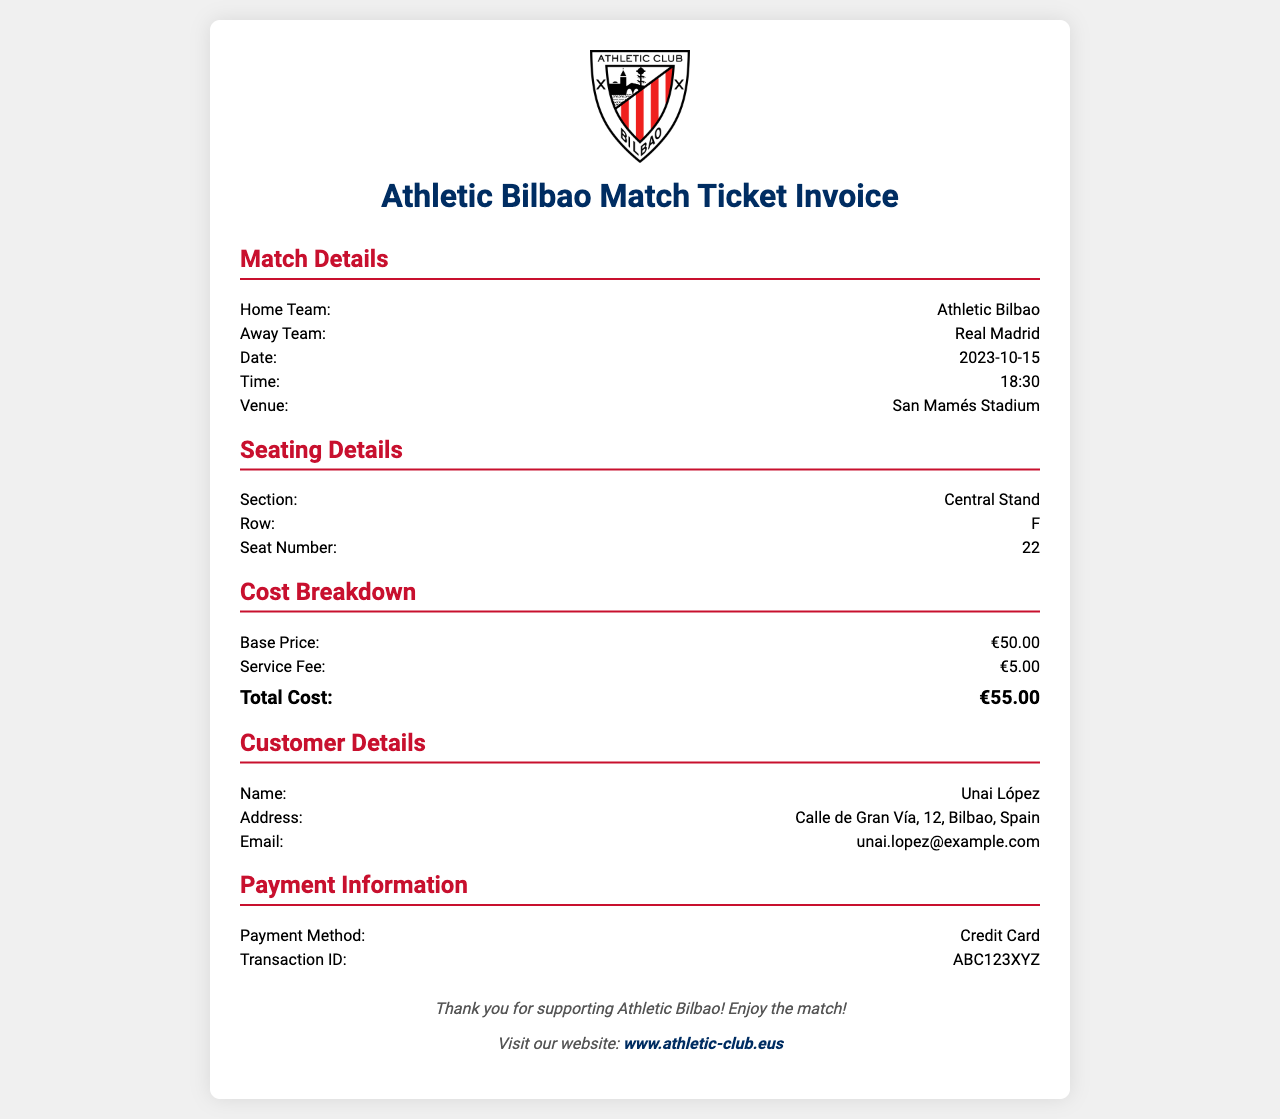What is the date of the match? The date of the match is provided in the match details section of the document.
Answer: 2023-10-15 Who is the away team? The away team is listed under the match details section of the document.
Answer: Real Madrid What is the section of the seat? The section of the seat is mentioned in the seating details section.
Answer: Central Stand What is the total cost of the ticket? The total cost of the ticket is summarized in the cost breakdown section of the document.
Answer: €55.00 What payment method was used? The payment method is provided in the payment information section of the document.
Answer: Credit Card What is the customer's name? The customer's name is located in the customer details section of the document.
Answer: Unai López How much is the service fee? The service fee is specified in the cost breakdown, which details the pricing components.
Answer: €5.00 What is the row number of the seat? The row number of the seat is found in the seating details section.
Answer: F 